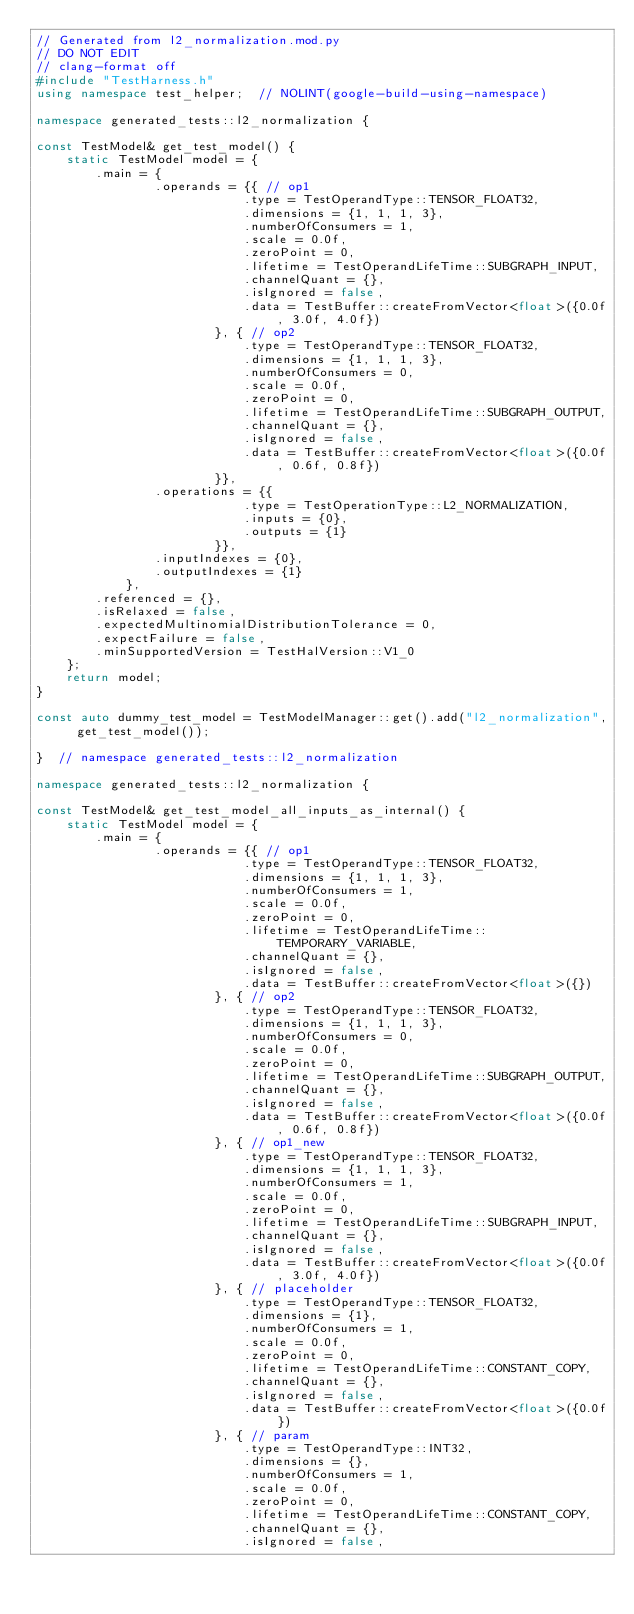<code> <loc_0><loc_0><loc_500><loc_500><_C++_>// Generated from l2_normalization.mod.py
// DO NOT EDIT
// clang-format off
#include "TestHarness.h"
using namespace test_helper;  // NOLINT(google-build-using-namespace)

namespace generated_tests::l2_normalization {

const TestModel& get_test_model() {
    static TestModel model = {
        .main = {
                .operands = {{ // op1
                            .type = TestOperandType::TENSOR_FLOAT32,
                            .dimensions = {1, 1, 1, 3},
                            .numberOfConsumers = 1,
                            .scale = 0.0f,
                            .zeroPoint = 0,
                            .lifetime = TestOperandLifeTime::SUBGRAPH_INPUT,
                            .channelQuant = {},
                            .isIgnored = false,
                            .data = TestBuffer::createFromVector<float>({0.0f, 3.0f, 4.0f})
                        }, { // op2
                            .type = TestOperandType::TENSOR_FLOAT32,
                            .dimensions = {1, 1, 1, 3},
                            .numberOfConsumers = 0,
                            .scale = 0.0f,
                            .zeroPoint = 0,
                            .lifetime = TestOperandLifeTime::SUBGRAPH_OUTPUT,
                            .channelQuant = {},
                            .isIgnored = false,
                            .data = TestBuffer::createFromVector<float>({0.0f, 0.6f, 0.8f})
                        }},
                .operations = {{
                            .type = TestOperationType::L2_NORMALIZATION,
                            .inputs = {0},
                            .outputs = {1}
                        }},
                .inputIndexes = {0},
                .outputIndexes = {1}
            },
        .referenced = {},
        .isRelaxed = false,
        .expectedMultinomialDistributionTolerance = 0,
        .expectFailure = false,
        .minSupportedVersion = TestHalVersion::V1_0
    };
    return model;
}

const auto dummy_test_model = TestModelManager::get().add("l2_normalization", get_test_model());

}  // namespace generated_tests::l2_normalization

namespace generated_tests::l2_normalization {

const TestModel& get_test_model_all_inputs_as_internal() {
    static TestModel model = {
        .main = {
                .operands = {{ // op1
                            .type = TestOperandType::TENSOR_FLOAT32,
                            .dimensions = {1, 1, 1, 3},
                            .numberOfConsumers = 1,
                            .scale = 0.0f,
                            .zeroPoint = 0,
                            .lifetime = TestOperandLifeTime::TEMPORARY_VARIABLE,
                            .channelQuant = {},
                            .isIgnored = false,
                            .data = TestBuffer::createFromVector<float>({})
                        }, { // op2
                            .type = TestOperandType::TENSOR_FLOAT32,
                            .dimensions = {1, 1, 1, 3},
                            .numberOfConsumers = 0,
                            .scale = 0.0f,
                            .zeroPoint = 0,
                            .lifetime = TestOperandLifeTime::SUBGRAPH_OUTPUT,
                            .channelQuant = {},
                            .isIgnored = false,
                            .data = TestBuffer::createFromVector<float>({0.0f, 0.6f, 0.8f})
                        }, { // op1_new
                            .type = TestOperandType::TENSOR_FLOAT32,
                            .dimensions = {1, 1, 1, 3},
                            .numberOfConsumers = 1,
                            .scale = 0.0f,
                            .zeroPoint = 0,
                            .lifetime = TestOperandLifeTime::SUBGRAPH_INPUT,
                            .channelQuant = {},
                            .isIgnored = false,
                            .data = TestBuffer::createFromVector<float>({0.0f, 3.0f, 4.0f})
                        }, { // placeholder
                            .type = TestOperandType::TENSOR_FLOAT32,
                            .dimensions = {1},
                            .numberOfConsumers = 1,
                            .scale = 0.0f,
                            .zeroPoint = 0,
                            .lifetime = TestOperandLifeTime::CONSTANT_COPY,
                            .channelQuant = {},
                            .isIgnored = false,
                            .data = TestBuffer::createFromVector<float>({0.0f})
                        }, { // param
                            .type = TestOperandType::INT32,
                            .dimensions = {},
                            .numberOfConsumers = 1,
                            .scale = 0.0f,
                            .zeroPoint = 0,
                            .lifetime = TestOperandLifeTime::CONSTANT_COPY,
                            .channelQuant = {},
                            .isIgnored = false,</code> 